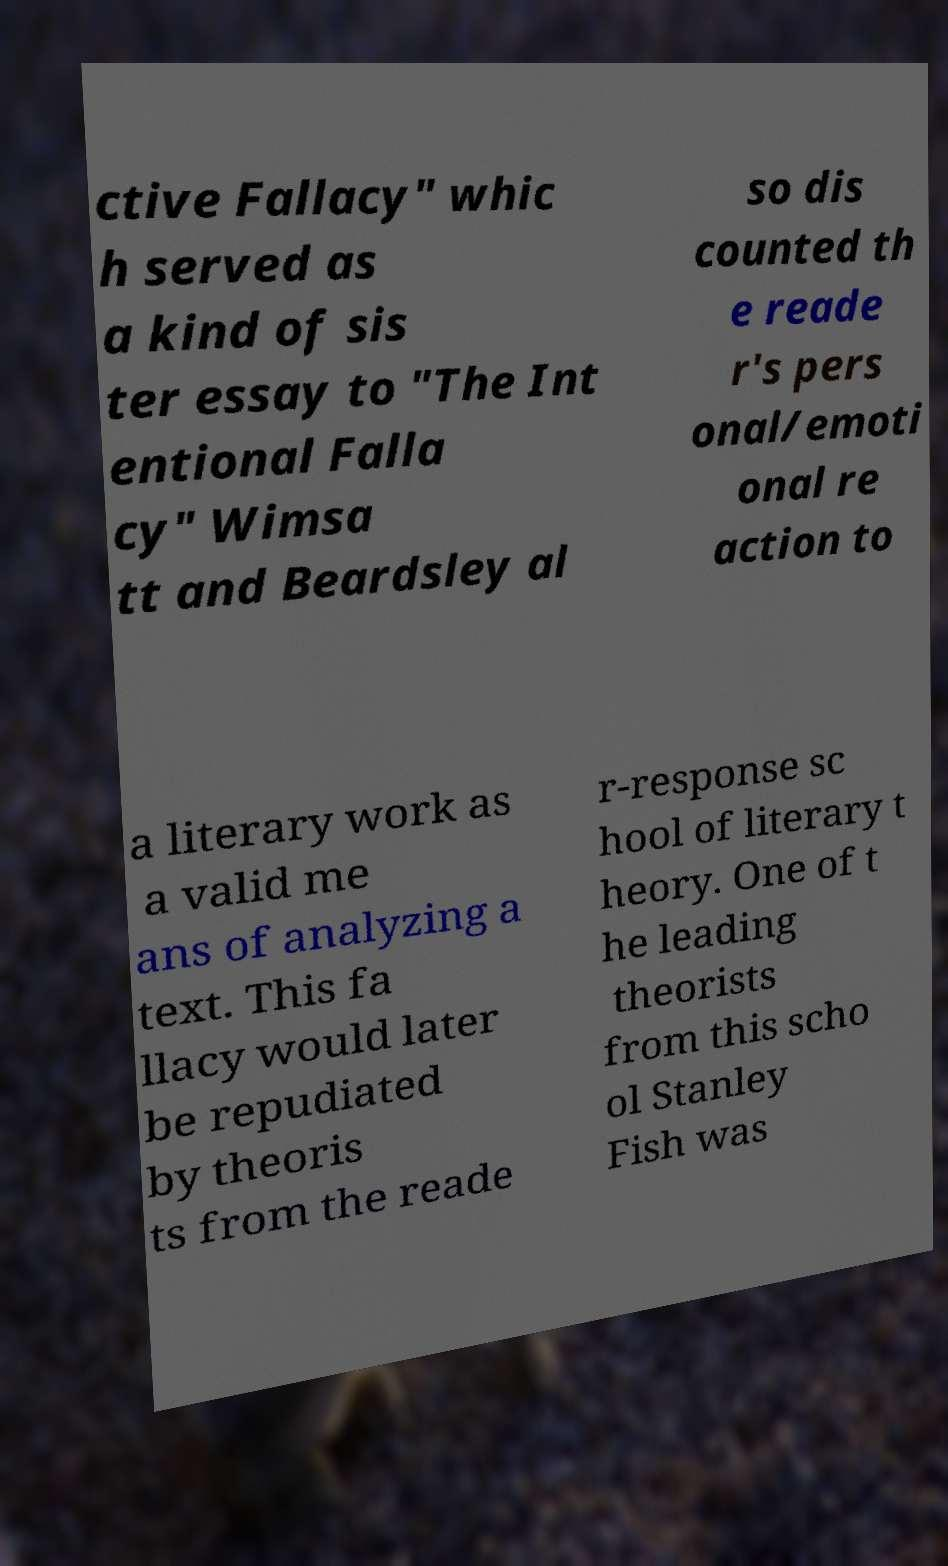Could you extract and type out the text from this image? ctive Fallacy" whic h served as a kind of sis ter essay to "The Int entional Falla cy" Wimsa tt and Beardsley al so dis counted th e reade r's pers onal/emoti onal re action to a literary work as a valid me ans of analyzing a text. This fa llacy would later be repudiated by theoris ts from the reade r-response sc hool of literary t heory. One of t he leading theorists from this scho ol Stanley Fish was 